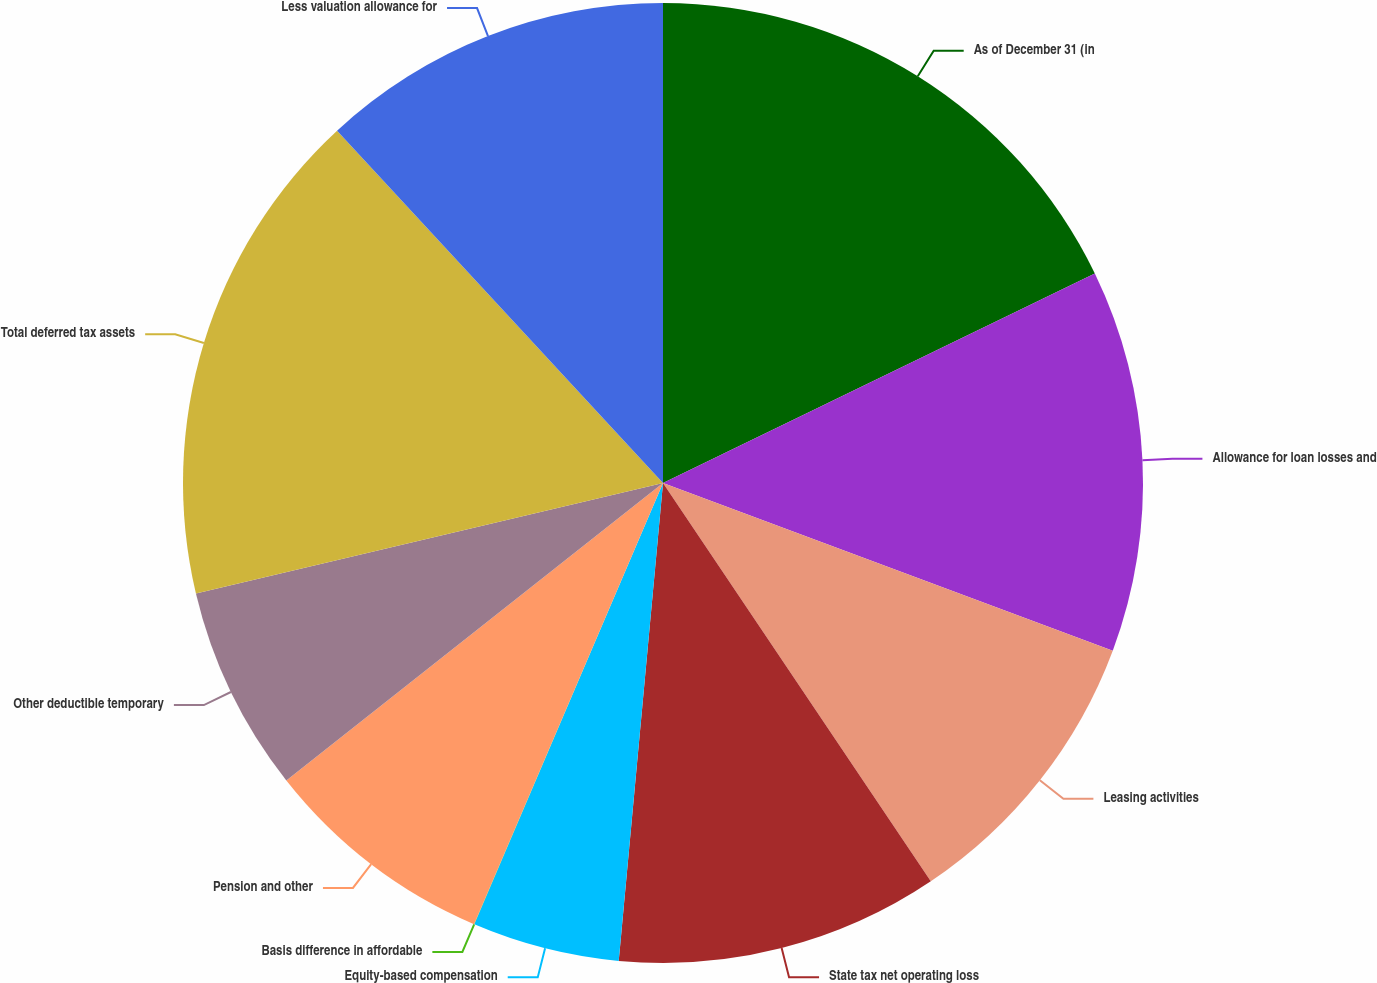<chart> <loc_0><loc_0><loc_500><loc_500><pie_chart><fcel>As of December 31 (in<fcel>Allowance for loan losses and<fcel>Leasing activities<fcel>State tax net operating loss<fcel>Equity-based compensation<fcel>Basis difference in affordable<fcel>Pension and other<fcel>Other deductible temporary<fcel>Total deferred tax assets<fcel>Less valuation allowance for<nl><fcel>17.81%<fcel>12.87%<fcel>9.9%<fcel>10.89%<fcel>4.96%<fcel>0.01%<fcel>7.92%<fcel>6.94%<fcel>16.82%<fcel>11.88%<nl></chart> 